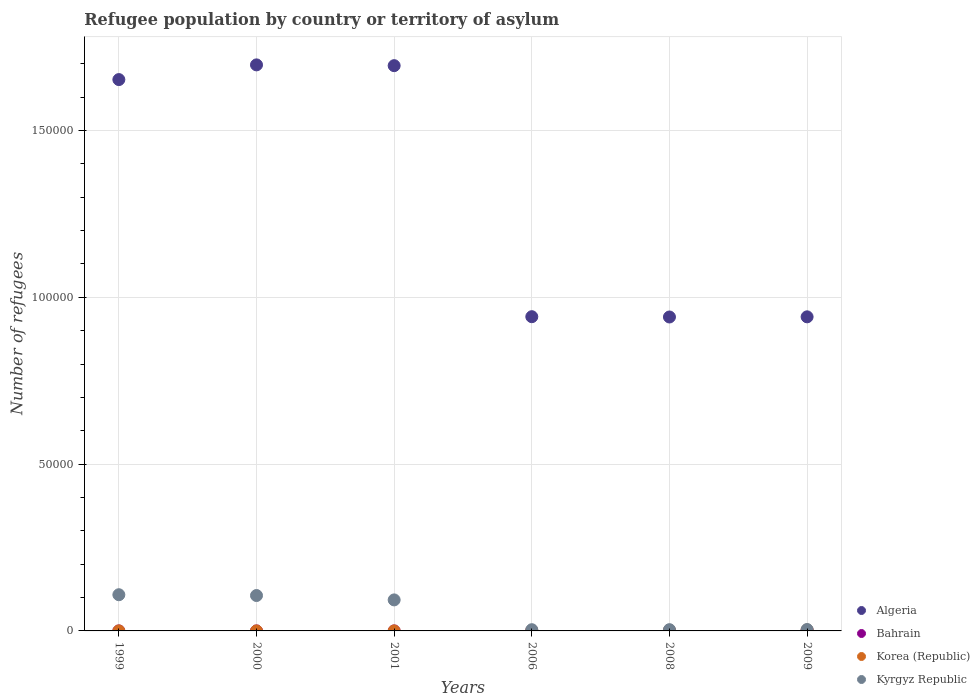Across all years, what is the maximum number of refugees in Algeria?
Provide a short and direct response. 1.70e+05. Across all years, what is the minimum number of refugees in Kyrgyz Republic?
Give a very brief answer. 366. In which year was the number of refugees in Kyrgyz Republic maximum?
Keep it short and to the point. 1999. What is the total number of refugees in Kyrgyz Republic in the graph?
Provide a short and direct response. 3.19e+04. What is the difference between the number of refugees in Bahrain in 2001 and that in 2008?
Offer a terse response. -47. What is the difference between the number of refugees in Kyrgyz Republic in 2009 and the number of refugees in Korea (Republic) in 2008?
Your answer should be very brief. 251. What is the average number of refugees in Korea (Republic) per year?
Provide a short and direct response. 92.67. In the year 2001, what is the difference between the number of refugees in Korea (Republic) and number of refugees in Kyrgyz Republic?
Give a very brief answer. -9289. What is the ratio of the number of refugees in Algeria in 2000 to that in 2001?
Provide a succinct answer. 1. Is the number of refugees in Bahrain in 1999 less than that in 2008?
Your response must be concise. Yes. Is the difference between the number of refugees in Korea (Republic) in 2000 and 2001 greater than the difference between the number of refugees in Kyrgyz Republic in 2000 and 2001?
Give a very brief answer. No. What is the difference between the highest and the second highest number of refugees in Algeria?
Your answer should be compact. 234. What is the difference between the highest and the lowest number of refugees in Algeria?
Your answer should be very brief. 7.56e+04. Is the number of refugees in Korea (Republic) strictly less than the number of refugees in Algeria over the years?
Ensure brevity in your answer.  Yes. How many dotlines are there?
Your response must be concise. 4. How many years are there in the graph?
Offer a very short reply. 6. Are the values on the major ticks of Y-axis written in scientific E-notation?
Provide a succinct answer. No. Does the graph contain grids?
Offer a terse response. Yes. Where does the legend appear in the graph?
Offer a terse response. Bottom right. How many legend labels are there?
Give a very brief answer. 4. What is the title of the graph?
Your answer should be very brief. Refugee population by country or territory of asylum. What is the label or title of the X-axis?
Provide a short and direct response. Years. What is the label or title of the Y-axis?
Provide a succinct answer. Number of refugees. What is the Number of refugees of Algeria in 1999?
Make the answer very short. 1.65e+05. What is the Number of refugees in Bahrain in 1999?
Give a very brief answer. 1. What is the Number of refugees in Kyrgyz Republic in 1999?
Your answer should be compact. 1.08e+04. What is the Number of refugees of Algeria in 2000?
Keep it short and to the point. 1.70e+05. What is the Number of refugees of Korea (Republic) in 2000?
Your response must be concise. 6. What is the Number of refugees in Kyrgyz Republic in 2000?
Offer a very short reply. 1.06e+04. What is the Number of refugees in Algeria in 2001?
Ensure brevity in your answer.  1.69e+05. What is the Number of refugees of Kyrgyz Republic in 2001?
Your answer should be compact. 9296. What is the Number of refugees of Algeria in 2006?
Make the answer very short. 9.42e+04. What is the Number of refugees of Bahrain in 2006?
Give a very brief answer. 1. What is the Number of refugees of Korea (Republic) in 2006?
Your response must be concise. 96. What is the Number of refugees in Kyrgyz Republic in 2006?
Give a very brief answer. 366. What is the Number of refugees in Algeria in 2008?
Provide a short and direct response. 9.41e+04. What is the Number of refugees of Bahrain in 2008?
Your answer should be compact. 48. What is the Number of refugees of Korea (Republic) in 2008?
Your response must be concise. 172. What is the Number of refugees in Kyrgyz Republic in 2008?
Offer a terse response. 375. What is the Number of refugees in Algeria in 2009?
Give a very brief answer. 9.41e+04. What is the Number of refugees of Bahrain in 2009?
Provide a succinct answer. 139. What is the Number of refugees of Korea (Republic) in 2009?
Your response must be concise. 268. What is the Number of refugees in Kyrgyz Republic in 2009?
Make the answer very short. 423. Across all years, what is the maximum Number of refugees of Algeria?
Your response must be concise. 1.70e+05. Across all years, what is the maximum Number of refugees of Bahrain?
Offer a terse response. 139. Across all years, what is the maximum Number of refugees of Korea (Republic)?
Provide a succinct answer. 268. Across all years, what is the maximum Number of refugees of Kyrgyz Republic?
Provide a succinct answer. 1.08e+04. Across all years, what is the minimum Number of refugees in Algeria?
Make the answer very short. 9.41e+04. Across all years, what is the minimum Number of refugees of Bahrain?
Your answer should be compact. 1. Across all years, what is the minimum Number of refugees of Kyrgyz Republic?
Keep it short and to the point. 366. What is the total Number of refugees in Algeria in the graph?
Your answer should be compact. 7.87e+05. What is the total Number of refugees of Bahrain in the graph?
Provide a succinct answer. 191. What is the total Number of refugees of Korea (Republic) in the graph?
Provide a succinct answer. 556. What is the total Number of refugees in Kyrgyz Republic in the graph?
Your response must be concise. 3.19e+04. What is the difference between the Number of refugees in Algeria in 1999 and that in 2000?
Offer a very short reply. -4407. What is the difference between the Number of refugees in Bahrain in 1999 and that in 2000?
Ensure brevity in your answer.  0. What is the difference between the Number of refugees in Korea (Republic) in 1999 and that in 2000?
Your answer should be very brief. 1. What is the difference between the Number of refugees in Kyrgyz Republic in 1999 and that in 2000?
Ensure brevity in your answer.  240. What is the difference between the Number of refugees of Algeria in 1999 and that in 2001?
Your answer should be compact. -4173. What is the difference between the Number of refugees of Bahrain in 1999 and that in 2001?
Provide a short and direct response. 0. What is the difference between the Number of refugees of Kyrgyz Republic in 1999 and that in 2001?
Your answer should be compact. 1553. What is the difference between the Number of refugees in Algeria in 1999 and that in 2006?
Your answer should be very brief. 7.11e+04. What is the difference between the Number of refugees of Korea (Republic) in 1999 and that in 2006?
Offer a very short reply. -89. What is the difference between the Number of refugees in Kyrgyz Republic in 1999 and that in 2006?
Offer a terse response. 1.05e+04. What is the difference between the Number of refugees of Algeria in 1999 and that in 2008?
Give a very brief answer. 7.12e+04. What is the difference between the Number of refugees of Bahrain in 1999 and that in 2008?
Your answer should be very brief. -47. What is the difference between the Number of refugees in Korea (Republic) in 1999 and that in 2008?
Keep it short and to the point. -165. What is the difference between the Number of refugees in Kyrgyz Republic in 1999 and that in 2008?
Give a very brief answer. 1.05e+04. What is the difference between the Number of refugees in Algeria in 1999 and that in 2009?
Your response must be concise. 7.11e+04. What is the difference between the Number of refugees in Bahrain in 1999 and that in 2009?
Give a very brief answer. -138. What is the difference between the Number of refugees in Korea (Republic) in 1999 and that in 2009?
Your response must be concise. -261. What is the difference between the Number of refugees in Kyrgyz Republic in 1999 and that in 2009?
Your response must be concise. 1.04e+04. What is the difference between the Number of refugees of Algeria in 2000 and that in 2001?
Your response must be concise. 234. What is the difference between the Number of refugees of Korea (Republic) in 2000 and that in 2001?
Provide a succinct answer. -1. What is the difference between the Number of refugees in Kyrgyz Republic in 2000 and that in 2001?
Give a very brief answer. 1313. What is the difference between the Number of refugees in Algeria in 2000 and that in 2006?
Provide a succinct answer. 7.55e+04. What is the difference between the Number of refugees of Korea (Republic) in 2000 and that in 2006?
Your answer should be very brief. -90. What is the difference between the Number of refugees of Kyrgyz Republic in 2000 and that in 2006?
Your answer should be very brief. 1.02e+04. What is the difference between the Number of refugees of Algeria in 2000 and that in 2008?
Keep it short and to the point. 7.56e+04. What is the difference between the Number of refugees of Bahrain in 2000 and that in 2008?
Offer a terse response. -47. What is the difference between the Number of refugees in Korea (Republic) in 2000 and that in 2008?
Ensure brevity in your answer.  -166. What is the difference between the Number of refugees in Kyrgyz Republic in 2000 and that in 2008?
Your response must be concise. 1.02e+04. What is the difference between the Number of refugees in Algeria in 2000 and that in 2009?
Offer a terse response. 7.55e+04. What is the difference between the Number of refugees in Bahrain in 2000 and that in 2009?
Offer a terse response. -138. What is the difference between the Number of refugees of Korea (Republic) in 2000 and that in 2009?
Ensure brevity in your answer.  -262. What is the difference between the Number of refugees of Kyrgyz Republic in 2000 and that in 2009?
Your response must be concise. 1.02e+04. What is the difference between the Number of refugees in Algeria in 2001 and that in 2006?
Your answer should be very brief. 7.52e+04. What is the difference between the Number of refugees of Korea (Republic) in 2001 and that in 2006?
Your answer should be very brief. -89. What is the difference between the Number of refugees of Kyrgyz Republic in 2001 and that in 2006?
Give a very brief answer. 8930. What is the difference between the Number of refugees of Algeria in 2001 and that in 2008?
Offer a very short reply. 7.53e+04. What is the difference between the Number of refugees of Bahrain in 2001 and that in 2008?
Keep it short and to the point. -47. What is the difference between the Number of refugees in Korea (Republic) in 2001 and that in 2008?
Your answer should be compact. -165. What is the difference between the Number of refugees of Kyrgyz Republic in 2001 and that in 2008?
Offer a very short reply. 8921. What is the difference between the Number of refugees in Algeria in 2001 and that in 2009?
Ensure brevity in your answer.  7.53e+04. What is the difference between the Number of refugees of Bahrain in 2001 and that in 2009?
Your response must be concise. -138. What is the difference between the Number of refugees in Korea (Republic) in 2001 and that in 2009?
Make the answer very short. -261. What is the difference between the Number of refugees of Kyrgyz Republic in 2001 and that in 2009?
Offer a very short reply. 8873. What is the difference between the Number of refugees of Algeria in 2006 and that in 2008?
Your answer should be very brief. 87. What is the difference between the Number of refugees in Bahrain in 2006 and that in 2008?
Offer a terse response. -47. What is the difference between the Number of refugees in Korea (Republic) in 2006 and that in 2008?
Your response must be concise. -76. What is the difference between the Number of refugees in Kyrgyz Republic in 2006 and that in 2008?
Give a very brief answer. -9. What is the difference between the Number of refugees of Algeria in 2006 and that in 2009?
Your answer should be very brief. 43. What is the difference between the Number of refugees of Bahrain in 2006 and that in 2009?
Offer a very short reply. -138. What is the difference between the Number of refugees in Korea (Republic) in 2006 and that in 2009?
Offer a terse response. -172. What is the difference between the Number of refugees in Kyrgyz Republic in 2006 and that in 2009?
Provide a short and direct response. -57. What is the difference between the Number of refugees of Algeria in 2008 and that in 2009?
Your answer should be very brief. -44. What is the difference between the Number of refugees of Bahrain in 2008 and that in 2009?
Ensure brevity in your answer.  -91. What is the difference between the Number of refugees of Korea (Republic) in 2008 and that in 2009?
Offer a very short reply. -96. What is the difference between the Number of refugees in Kyrgyz Republic in 2008 and that in 2009?
Offer a terse response. -48. What is the difference between the Number of refugees of Algeria in 1999 and the Number of refugees of Bahrain in 2000?
Offer a terse response. 1.65e+05. What is the difference between the Number of refugees of Algeria in 1999 and the Number of refugees of Korea (Republic) in 2000?
Ensure brevity in your answer.  1.65e+05. What is the difference between the Number of refugees of Algeria in 1999 and the Number of refugees of Kyrgyz Republic in 2000?
Provide a succinct answer. 1.55e+05. What is the difference between the Number of refugees in Bahrain in 1999 and the Number of refugees in Kyrgyz Republic in 2000?
Provide a short and direct response. -1.06e+04. What is the difference between the Number of refugees in Korea (Republic) in 1999 and the Number of refugees in Kyrgyz Republic in 2000?
Offer a terse response. -1.06e+04. What is the difference between the Number of refugees of Algeria in 1999 and the Number of refugees of Bahrain in 2001?
Your response must be concise. 1.65e+05. What is the difference between the Number of refugees in Algeria in 1999 and the Number of refugees in Korea (Republic) in 2001?
Your answer should be very brief. 1.65e+05. What is the difference between the Number of refugees of Algeria in 1999 and the Number of refugees of Kyrgyz Republic in 2001?
Offer a very short reply. 1.56e+05. What is the difference between the Number of refugees of Bahrain in 1999 and the Number of refugees of Kyrgyz Republic in 2001?
Your answer should be very brief. -9295. What is the difference between the Number of refugees in Korea (Republic) in 1999 and the Number of refugees in Kyrgyz Republic in 2001?
Offer a very short reply. -9289. What is the difference between the Number of refugees of Algeria in 1999 and the Number of refugees of Bahrain in 2006?
Give a very brief answer. 1.65e+05. What is the difference between the Number of refugees in Algeria in 1999 and the Number of refugees in Korea (Republic) in 2006?
Make the answer very short. 1.65e+05. What is the difference between the Number of refugees in Algeria in 1999 and the Number of refugees in Kyrgyz Republic in 2006?
Offer a terse response. 1.65e+05. What is the difference between the Number of refugees of Bahrain in 1999 and the Number of refugees of Korea (Republic) in 2006?
Keep it short and to the point. -95. What is the difference between the Number of refugees of Bahrain in 1999 and the Number of refugees of Kyrgyz Republic in 2006?
Your answer should be compact. -365. What is the difference between the Number of refugees in Korea (Republic) in 1999 and the Number of refugees in Kyrgyz Republic in 2006?
Your answer should be compact. -359. What is the difference between the Number of refugees of Algeria in 1999 and the Number of refugees of Bahrain in 2008?
Your answer should be very brief. 1.65e+05. What is the difference between the Number of refugees of Algeria in 1999 and the Number of refugees of Korea (Republic) in 2008?
Provide a succinct answer. 1.65e+05. What is the difference between the Number of refugees in Algeria in 1999 and the Number of refugees in Kyrgyz Republic in 2008?
Offer a very short reply. 1.65e+05. What is the difference between the Number of refugees in Bahrain in 1999 and the Number of refugees in Korea (Republic) in 2008?
Provide a succinct answer. -171. What is the difference between the Number of refugees of Bahrain in 1999 and the Number of refugees of Kyrgyz Republic in 2008?
Offer a terse response. -374. What is the difference between the Number of refugees of Korea (Republic) in 1999 and the Number of refugees of Kyrgyz Republic in 2008?
Make the answer very short. -368. What is the difference between the Number of refugees of Algeria in 1999 and the Number of refugees of Bahrain in 2009?
Give a very brief answer. 1.65e+05. What is the difference between the Number of refugees of Algeria in 1999 and the Number of refugees of Korea (Republic) in 2009?
Provide a short and direct response. 1.65e+05. What is the difference between the Number of refugees of Algeria in 1999 and the Number of refugees of Kyrgyz Republic in 2009?
Offer a terse response. 1.65e+05. What is the difference between the Number of refugees in Bahrain in 1999 and the Number of refugees in Korea (Republic) in 2009?
Your answer should be compact. -267. What is the difference between the Number of refugees in Bahrain in 1999 and the Number of refugees in Kyrgyz Republic in 2009?
Your answer should be very brief. -422. What is the difference between the Number of refugees in Korea (Republic) in 1999 and the Number of refugees in Kyrgyz Republic in 2009?
Keep it short and to the point. -416. What is the difference between the Number of refugees in Algeria in 2000 and the Number of refugees in Bahrain in 2001?
Ensure brevity in your answer.  1.70e+05. What is the difference between the Number of refugees in Algeria in 2000 and the Number of refugees in Korea (Republic) in 2001?
Give a very brief answer. 1.70e+05. What is the difference between the Number of refugees in Algeria in 2000 and the Number of refugees in Kyrgyz Republic in 2001?
Your answer should be compact. 1.60e+05. What is the difference between the Number of refugees in Bahrain in 2000 and the Number of refugees in Kyrgyz Republic in 2001?
Your response must be concise. -9295. What is the difference between the Number of refugees of Korea (Republic) in 2000 and the Number of refugees of Kyrgyz Republic in 2001?
Provide a succinct answer. -9290. What is the difference between the Number of refugees in Algeria in 2000 and the Number of refugees in Bahrain in 2006?
Your response must be concise. 1.70e+05. What is the difference between the Number of refugees of Algeria in 2000 and the Number of refugees of Korea (Republic) in 2006?
Provide a succinct answer. 1.70e+05. What is the difference between the Number of refugees of Algeria in 2000 and the Number of refugees of Kyrgyz Republic in 2006?
Provide a succinct answer. 1.69e+05. What is the difference between the Number of refugees of Bahrain in 2000 and the Number of refugees of Korea (Republic) in 2006?
Provide a succinct answer. -95. What is the difference between the Number of refugees of Bahrain in 2000 and the Number of refugees of Kyrgyz Republic in 2006?
Keep it short and to the point. -365. What is the difference between the Number of refugees in Korea (Republic) in 2000 and the Number of refugees in Kyrgyz Republic in 2006?
Ensure brevity in your answer.  -360. What is the difference between the Number of refugees of Algeria in 2000 and the Number of refugees of Bahrain in 2008?
Your answer should be compact. 1.70e+05. What is the difference between the Number of refugees of Algeria in 2000 and the Number of refugees of Korea (Republic) in 2008?
Make the answer very short. 1.69e+05. What is the difference between the Number of refugees of Algeria in 2000 and the Number of refugees of Kyrgyz Republic in 2008?
Ensure brevity in your answer.  1.69e+05. What is the difference between the Number of refugees in Bahrain in 2000 and the Number of refugees in Korea (Republic) in 2008?
Your answer should be compact. -171. What is the difference between the Number of refugees in Bahrain in 2000 and the Number of refugees in Kyrgyz Republic in 2008?
Ensure brevity in your answer.  -374. What is the difference between the Number of refugees of Korea (Republic) in 2000 and the Number of refugees of Kyrgyz Republic in 2008?
Your answer should be very brief. -369. What is the difference between the Number of refugees of Algeria in 2000 and the Number of refugees of Bahrain in 2009?
Ensure brevity in your answer.  1.70e+05. What is the difference between the Number of refugees in Algeria in 2000 and the Number of refugees in Korea (Republic) in 2009?
Your response must be concise. 1.69e+05. What is the difference between the Number of refugees in Algeria in 2000 and the Number of refugees in Kyrgyz Republic in 2009?
Ensure brevity in your answer.  1.69e+05. What is the difference between the Number of refugees of Bahrain in 2000 and the Number of refugees of Korea (Republic) in 2009?
Provide a succinct answer. -267. What is the difference between the Number of refugees in Bahrain in 2000 and the Number of refugees in Kyrgyz Republic in 2009?
Provide a succinct answer. -422. What is the difference between the Number of refugees of Korea (Republic) in 2000 and the Number of refugees of Kyrgyz Republic in 2009?
Give a very brief answer. -417. What is the difference between the Number of refugees in Algeria in 2001 and the Number of refugees in Bahrain in 2006?
Ensure brevity in your answer.  1.69e+05. What is the difference between the Number of refugees in Algeria in 2001 and the Number of refugees in Korea (Republic) in 2006?
Provide a short and direct response. 1.69e+05. What is the difference between the Number of refugees in Algeria in 2001 and the Number of refugees in Kyrgyz Republic in 2006?
Provide a succinct answer. 1.69e+05. What is the difference between the Number of refugees in Bahrain in 2001 and the Number of refugees in Korea (Republic) in 2006?
Keep it short and to the point. -95. What is the difference between the Number of refugees of Bahrain in 2001 and the Number of refugees of Kyrgyz Republic in 2006?
Your answer should be compact. -365. What is the difference between the Number of refugees of Korea (Republic) in 2001 and the Number of refugees of Kyrgyz Republic in 2006?
Ensure brevity in your answer.  -359. What is the difference between the Number of refugees of Algeria in 2001 and the Number of refugees of Bahrain in 2008?
Offer a terse response. 1.69e+05. What is the difference between the Number of refugees of Algeria in 2001 and the Number of refugees of Korea (Republic) in 2008?
Give a very brief answer. 1.69e+05. What is the difference between the Number of refugees of Algeria in 2001 and the Number of refugees of Kyrgyz Republic in 2008?
Keep it short and to the point. 1.69e+05. What is the difference between the Number of refugees of Bahrain in 2001 and the Number of refugees of Korea (Republic) in 2008?
Your response must be concise. -171. What is the difference between the Number of refugees of Bahrain in 2001 and the Number of refugees of Kyrgyz Republic in 2008?
Give a very brief answer. -374. What is the difference between the Number of refugees in Korea (Republic) in 2001 and the Number of refugees in Kyrgyz Republic in 2008?
Your answer should be very brief. -368. What is the difference between the Number of refugees in Algeria in 2001 and the Number of refugees in Bahrain in 2009?
Your answer should be compact. 1.69e+05. What is the difference between the Number of refugees in Algeria in 2001 and the Number of refugees in Korea (Republic) in 2009?
Ensure brevity in your answer.  1.69e+05. What is the difference between the Number of refugees of Algeria in 2001 and the Number of refugees of Kyrgyz Republic in 2009?
Provide a short and direct response. 1.69e+05. What is the difference between the Number of refugees in Bahrain in 2001 and the Number of refugees in Korea (Republic) in 2009?
Provide a short and direct response. -267. What is the difference between the Number of refugees of Bahrain in 2001 and the Number of refugees of Kyrgyz Republic in 2009?
Your response must be concise. -422. What is the difference between the Number of refugees in Korea (Republic) in 2001 and the Number of refugees in Kyrgyz Republic in 2009?
Your answer should be compact. -416. What is the difference between the Number of refugees in Algeria in 2006 and the Number of refugees in Bahrain in 2008?
Provide a succinct answer. 9.41e+04. What is the difference between the Number of refugees in Algeria in 2006 and the Number of refugees in Korea (Republic) in 2008?
Make the answer very short. 9.40e+04. What is the difference between the Number of refugees of Algeria in 2006 and the Number of refugees of Kyrgyz Republic in 2008?
Your response must be concise. 9.38e+04. What is the difference between the Number of refugees in Bahrain in 2006 and the Number of refugees in Korea (Republic) in 2008?
Your response must be concise. -171. What is the difference between the Number of refugees of Bahrain in 2006 and the Number of refugees of Kyrgyz Republic in 2008?
Offer a terse response. -374. What is the difference between the Number of refugees in Korea (Republic) in 2006 and the Number of refugees in Kyrgyz Republic in 2008?
Offer a very short reply. -279. What is the difference between the Number of refugees of Algeria in 2006 and the Number of refugees of Bahrain in 2009?
Your answer should be very brief. 9.40e+04. What is the difference between the Number of refugees in Algeria in 2006 and the Number of refugees in Korea (Republic) in 2009?
Your response must be concise. 9.39e+04. What is the difference between the Number of refugees of Algeria in 2006 and the Number of refugees of Kyrgyz Republic in 2009?
Your response must be concise. 9.38e+04. What is the difference between the Number of refugees of Bahrain in 2006 and the Number of refugees of Korea (Republic) in 2009?
Make the answer very short. -267. What is the difference between the Number of refugees in Bahrain in 2006 and the Number of refugees in Kyrgyz Republic in 2009?
Provide a short and direct response. -422. What is the difference between the Number of refugees of Korea (Republic) in 2006 and the Number of refugees of Kyrgyz Republic in 2009?
Your answer should be very brief. -327. What is the difference between the Number of refugees of Algeria in 2008 and the Number of refugees of Bahrain in 2009?
Offer a very short reply. 9.40e+04. What is the difference between the Number of refugees in Algeria in 2008 and the Number of refugees in Korea (Republic) in 2009?
Your answer should be compact. 9.38e+04. What is the difference between the Number of refugees of Algeria in 2008 and the Number of refugees of Kyrgyz Republic in 2009?
Offer a very short reply. 9.37e+04. What is the difference between the Number of refugees of Bahrain in 2008 and the Number of refugees of Korea (Republic) in 2009?
Provide a succinct answer. -220. What is the difference between the Number of refugees of Bahrain in 2008 and the Number of refugees of Kyrgyz Republic in 2009?
Your answer should be compact. -375. What is the difference between the Number of refugees in Korea (Republic) in 2008 and the Number of refugees in Kyrgyz Republic in 2009?
Make the answer very short. -251. What is the average Number of refugees of Algeria per year?
Provide a succinct answer. 1.31e+05. What is the average Number of refugees of Bahrain per year?
Keep it short and to the point. 31.83. What is the average Number of refugees in Korea (Republic) per year?
Your answer should be compact. 92.67. What is the average Number of refugees of Kyrgyz Republic per year?
Offer a terse response. 5319.67. In the year 1999, what is the difference between the Number of refugees in Algeria and Number of refugees in Bahrain?
Provide a short and direct response. 1.65e+05. In the year 1999, what is the difference between the Number of refugees in Algeria and Number of refugees in Korea (Republic)?
Offer a terse response. 1.65e+05. In the year 1999, what is the difference between the Number of refugees of Algeria and Number of refugees of Kyrgyz Republic?
Offer a very short reply. 1.54e+05. In the year 1999, what is the difference between the Number of refugees of Bahrain and Number of refugees of Kyrgyz Republic?
Offer a terse response. -1.08e+04. In the year 1999, what is the difference between the Number of refugees of Korea (Republic) and Number of refugees of Kyrgyz Republic?
Offer a terse response. -1.08e+04. In the year 2000, what is the difference between the Number of refugees of Algeria and Number of refugees of Bahrain?
Provide a short and direct response. 1.70e+05. In the year 2000, what is the difference between the Number of refugees in Algeria and Number of refugees in Korea (Republic)?
Your answer should be compact. 1.70e+05. In the year 2000, what is the difference between the Number of refugees of Algeria and Number of refugees of Kyrgyz Republic?
Provide a short and direct response. 1.59e+05. In the year 2000, what is the difference between the Number of refugees in Bahrain and Number of refugees in Korea (Republic)?
Your answer should be compact. -5. In the year 2000, what is the difference between the Number of refugees in Bahrain and Number of refugees in Kyrgyz Republic?
Offer a very short reply. -1.06e+04. In the year 2000, what is the difference between the Number of refugees in Korea (Republic) and Number of refugees in Kyrgyz Republic?
Your response must be concise. -1.06e+04. In the year 2001, what is the difference between the Number of refugees of Algeria and Number of refugees of Bahrain?
Provide a short and direct response. 1.69e+05. In the year 2001, what is the difference between the Number of refugees of Algeria and Number of refugees of Korea (Republic)?
Your answer should be compact. 1.69e+05. In the year 2001, what is the difference between the Number of refugees of Algeria and Number of refugees of Kyrgyz Republic?
Your answer should be compact. 1.60e+05. In the year 2001, what is the difference between the Number of refugees in Bahrain and Number of refugees in Korea (Republic)?
Offer a terse response. -6. In the year 2001, what is the difference between the Number of refugees in Bahrain and Number of refugees in Kyrgyz Republic?
Make the answer very short. -9295. In the year 2001, what is the difference between the Number of refugees of Korea (Republic) and Number of refugees of Kyrgyz Republic?
Offer a terse response. -9289. In the year 2006, what is the difference between the Number of refugees in Algeria and Number of refugees in Bahrain?
Keep it short and to the point. 9.42e+04. In the year 2006, what is the difference between the Number of refugees in Algeria and Number of refugees in Korea (Republic)?
Give a very brief answer. 9.41e+04. In the year 2006, what is the difference between the Number of refugees of Algeria and Number of refugees of Kyrgyz Republic?
Provide a short and direct response. 9.38e+04. In the year 2006, what is the difference between the Number of refugees in Bahrain and Number of refugees in Korea (Republic)?
Your answer should be very brief. -95. In the year 2006, what is the difference between the Number of refugees in Bahrain and Number of refugees in Kyrgyz Republic?
Make the answer very short. -365. In the year 2006, what is the difference between the Number of refugees of Korea (Republic) and Number of refugees of Kyrgyz Republic?
Give a very brief answer. -270. In the year 2008, what is the difference between the Number of refugees of Algeria and Number of refugees of Bahrain?
Offer a very short reply. 9.40e+04. In the year 2008, what is the difference between the Number of refugees in Algeria and Number of refugees in Korea (Republic)?
Your answer should be very brief. 9.39e+04. In the year 2008, what is the difference between the Number of refugees of Algeria and Number of refugees of Kyrgyz Republic?
Ensure brevity in your answer.  9.37e+04. In the year 2008, what is the difference between the Number of refugees of Bahrain and Number of refugees of Korea (Republic)?
Keep it short and to the point. -124. In the year 2008, what is the difference between the Number of refugees in Bahrain and Number of refugees in Kyrgyz Republic?
Your answer should be compact. -327. In the year 2008, what is the difference between the Number of refugees of Korea (Republic) and Number of refugees of Kyrgyz Republic?
Ensure brevity in your answer.  -203. In the year 2009, what is the difference between the Number of refugees in Algeria and Number of refugees in Bahrain?
Offer a very short reply. 9.40e+04. In the year 2009, what is the difference between the Number of refugees in Algeria and Number of refugees in Korea (Republic)?
Your response must be concise. 9.39e+04. In the year 2009, what is the difference between the Number of refugees in Algeria and Number of refugees in Kyrgyz Republic?
Make the answer very short. 9.37e+04. In the year 2009, what is the difference between the Number of refugees in Bahrain and Number of refugees in Korea (Republic)?
Provide a short and direct response. -129. In the year 2009, what is the difference between the Number of refugees of Bahrain and Number of refugees of Kyrgyz Republic?
Make the answer very short. -284. In the year 2009, what is the difference between the Number of refugees of Korea (Republic) and Number of refugees of Kyrgyz Republic?
Provide a succinct answer. -155. What is the ratio of the Number of refugees of Kyrgyz Republic in 1999 to that in 2000?
Offer a terse response. 1.02. What is the ratio of the Number of refugees in Algeria in 1999 to that in 2001?
Provide a succinct answer. 0.98. What is the ratio of the Number of refugees of Kyrgyz Republic in 1999 to that in 2001?
Make the answer very short. 1.17. What is the ratio of the Number of refugees of Algeria in 1999 to that in 2006?
Your answer should be compact. 1.75. What is the ratio of the Number of refugees of Bahrain in 1999 to that in 2006?
Make the answer very short. 1. What is the ratio of the Number of refugees of Korea (Republic) in 1999 to that in 2006?
Provide a succinct answer. 0.07. What is the ratio of the Number of refugees in Kyrgyz Republic in 1999 to that in 2006?
Your answer should be very brief. 29.64. What is the ratio of the Number of refugees in Algeria in 1999 to that in 2008?
Provide a succinct answer. 1.76. What is the ratio of the Number of refugees in Bahrain in 1999 to that in 2008?
Keep it short and to the point. 0.02. What is the ratio of the Number of refugees of Korea (Republic) in 1999 to that in 2008?
Your answer should be compact. 0.04. What is the ratio of the Number of refugees in Kyrgyz Republic in 1999 to that in 2008?
Offer a terse response. 28.93. What is the ratio of the Number of refugees of Algeria in 1999 to that in 2009?
Your response must be concise. 1.76. What is the ratio of the Number of refugees in Bahrain in 1999 to that in 2009?
Ensure brevity in your answer.  0.01. What is the ratio of the Number of refugees of Korea (Republic) in 1999 to that in 2009?
Offer a very short reply. 0.03. What is the ratio of the Number of refugees in Kyrgyz Republic in 1999 to that in 2009?
Ensure brevity in your answer.  25.65. What is the ratio of the Number of refugees of Bahrain in 2000 to that in 2001?
Give a very brief answer. 1. What is the ratio of the Number of refugees of Korea (Republic) in 2000 to that in 2001?
Your response must be concise. 0.86. What is the ratio of the Number of refugees of Kyrgyz Republic in 2000 to that in 2001?
Provide a short and direct response. 1.14. What is the ratio of the Number of refugees in Algeria in 2000 to that in 2006?
Ensure brevity in your answer.  1.8. What is the ratio of the Number of refugees of Korea (Republic) in 2000 to that in 2006?
Give a very brief answer. 0.06. What is the ratio of the Number of refugees in Kyrgyz Republic in 2000 to that in 2006?
Give a very brief answer. 28.99. What is the ratio of the Number of refugees in Algeria in 2000 to that in 2008?
Your answer should be very brief. 1.8. What is the ratio of the Number of refugees in Bahrain in 2000 to that in 2008?
Ensure brevity in your answer.  0.02. What is the ratio of the Number of refugees in Korea (Republic) in 2000 to that in 2008?
Ensure brevity in your answer.  0.03. What is the ratio of the Number of refugees of Kyrgyz Republic in 2000 to that in 2008?
Provide a short and direct response. 28.29. What is the ratio of the Number of refugees in Algeria in 2000 to that in 2009?
Provide a succinct answer. 1.8. What is the ratio of the Number of refugees of Bahrain in 2000 to that in 2009?
Your response must be concise. 0.01. What is the ratio of the Number of refugees of Korea (Republic) in 2000 to that in 2009?
Keep it short and to the point. 0.02. What is the ratio of the Number of refugees in Kyrgyz Republic in 2000 to that in 2009?
Provide a short and direct response. 25.08. What is the ratio of the Number of refugees in Algeria in 2001 to that in 2006?
Your response must be concise. 1.8. What is the ratio of the Number of refugees of Korea (Republic) in 2001 to that in 2006?
Make the answer very short. 0.07. What is the ratio of the Number of refugees of Kyrgyz Republic in 2001 to that in 2006?
Your answer should be very brief. 25.4. What is the ratio of the Number of refugees in Algeria in 2001 to that in 2008?
Offer a terse response. 1.8. What is the ratio of the Number of refugees in Bahrain in 2001 to that in 2008?
Ensure brevity in your answer.  0.02. What is the ratio of the Number of refugees in Korea (Republic) in 2001 to that in 2008?
Provide a succinct answer. 0.04. What is the ratio of the Number of refugees in Kyrgyz Republic in 2001 to that in 2008?
Your response must be concise. 24.79. What is the ratio of the Number of refugees of Algeria in 2001 to that in 2009?
Provide a succinct answer. 1.8. What is the ratio of the Number of refugees of Bahrain in 2001 to that in 2009?
Your answer should be very brief. 0.01. What is the ratio of the Number of refugees in Korea (Republic) in 2001 to that in 2009?
Your answer should be very brief. 0.03. What is the ratio of the Number of refugees of Kyrgyz Republic in 2001 to that in 2009?
Your answer should be very brief. 21.98. What is the ratio of the Number of refugees in Algeria in 2006 to that in 2008?
Make the answer very short. 1. What is the ratio of the Number of refugees in Bahrain in 2006 to that in 2008?
Offer a very short reply. 0.02. What is the ratio of the Number of refugees of Korea (Republic) in 2006 to that in 2008?
Ensure brevity in your answer.  0.56. What is the ratio of the Number of refugees of Bahrain in 2006 to that in 2009?
Give a very brief answer. 0.01. What is the ratio of the Number of refugees of Korea (Republic) in 2006 to that in 2009?
Offer a terse response. 0.36. What is the ratio of the Number of refugees in Kyrgyz Republic in 2006 to that in 2009?
Give a very brief answer. 0.87. What is the ratio of the Number of refugees in Bahrain in 2008 to that in 2009?
Make the answer very short. 0.35. What is the ratio of the Number of refugees in Korea (Republic) in 2008 to that in 2009?
Keep it short and to the point. 0.64. What is the ratio of the Number of refugees in Kyrgyz Republic in 2008 to that in 2009?
Provide a short and direct response. 0.89. What is the difference between the highest and the second highest Number of refugees in Algeria?
Keep it short and to the point. 234. What is the difference between the highest and the second highest Number of refugees of Bahrain?
Make the answer very short. 91. What is the difference between the highest and the second highest Number of refugees in Korea (Republic)?
Your answer should be very brief. 96. What is the difference between the highest and the second highest Number of refugees in Kyrgyz Republic?
Your answer should be very brief. 240. What is the difference between the highest and the lowest Number of refugees of Algeria?
Give a very brief answer. 7.56e+04. What is the difference between the highest and the lowest Number of refugees in Bahrain?
Provide a short and direct response. 138. What is the difference between the highest and the lowest Number of refugees of Korea (Republic)?
Offer a very short reply. 262. What is the difference between the highest and the lowest Number of refugees of Kyrgyz Republic?
Give a very brief answer. 1.05e+04. 